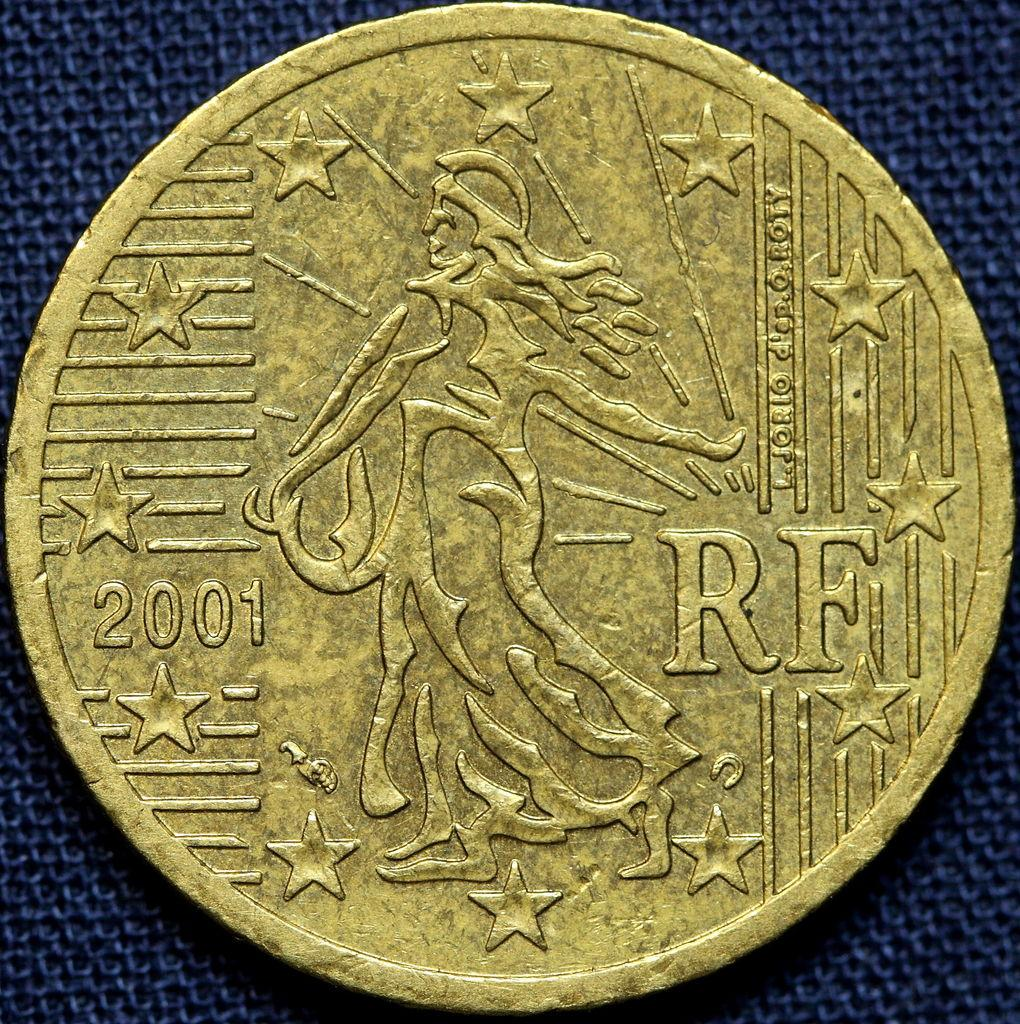<image>
Provide a brief description of the given image. A gold coin with RF on the right side and 2001 on the left. 